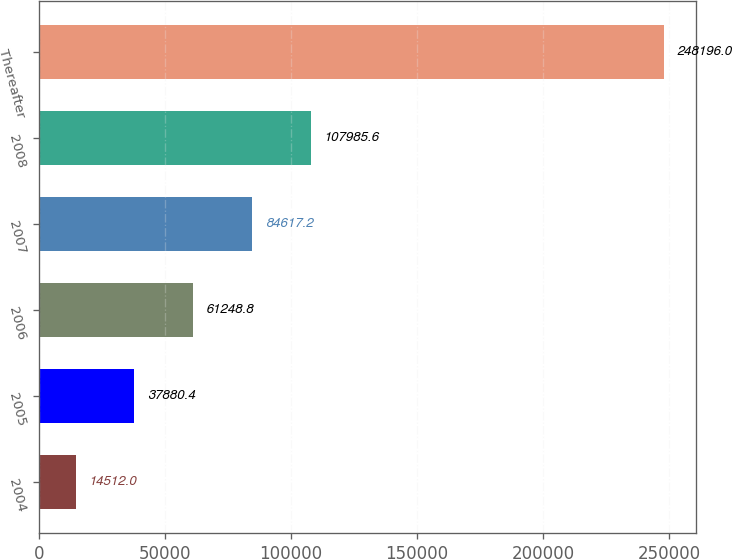Convert chart to OTSL. <chart><loc_0><loc_0><loc_500><loc_500><bar_chart><fcel>2004<fcel>2005<fcel>2006<fcel>2007<fcel>2008<fcel>Thereafter<nl><fcel>14512<fcel>37880.4<fcel>61248.8<fcel>84617.2<fcel>107986<fcel>248196<nl></chart> 